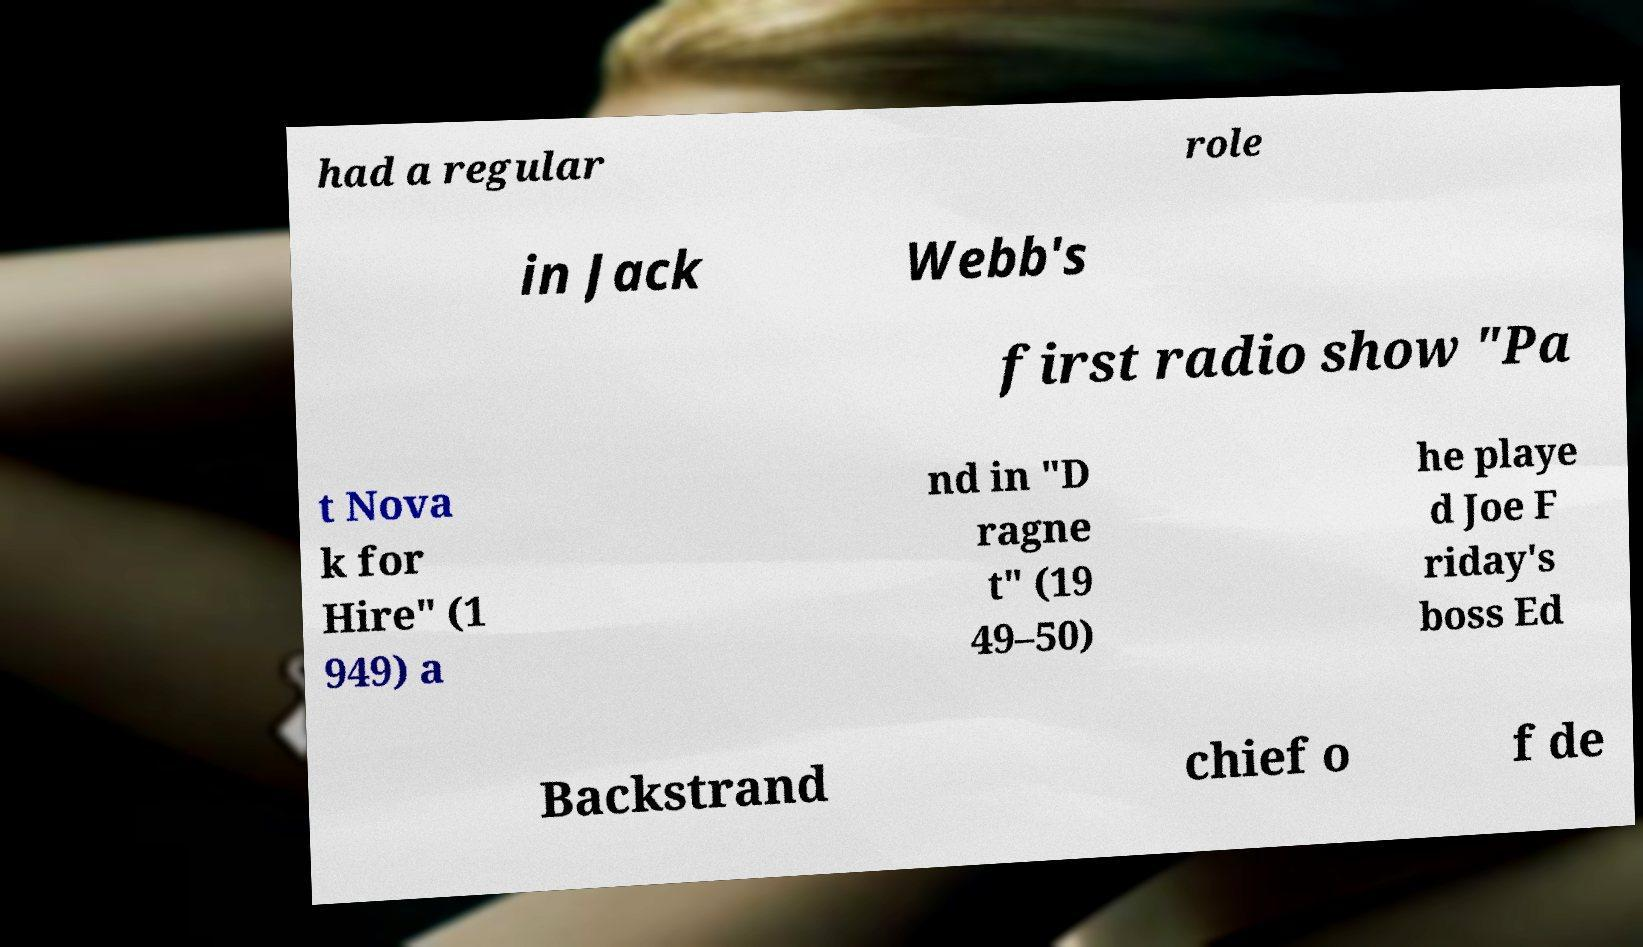Please read and relay the text visible in this image. What does it say? had a regular role in Jack Webb's first radio show "Pa t Nova k for Hire" (1 949) a nd in "D ragne t" (19 49–50) he playe d Joe F riday's boss Ed Backstrand chief o f de 